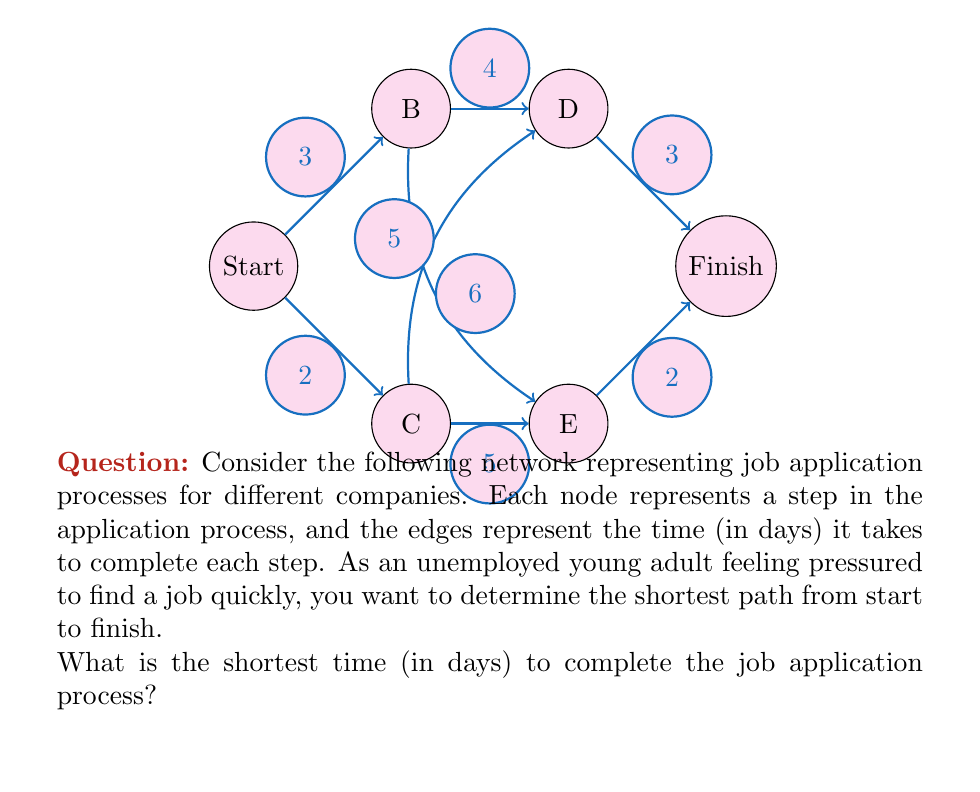Provide a solution to this math problem. To find the shortest path, we can use Dijkstra's algorithm or simply examine all possible paths from Start to Finish. Let's list all paths and their total times:

1. Start → B → D → Finish
   Time: $3 + 4 + 3 = 10$ days

2. Start → B → E → Finish
   Time: $3 + 6 + 2 = 11$ days

3. Start → C → D → Finish
   Time: $2 + 5 + 3 = 10$ days

4. Start → C → E → Finish
   Time: $2 + 5 + 2 = 9$ days

The shortest path is Start → C → E → Finish, taking 9 days in total.

This path represents:
1. Applying to company C (2 days)
2. Moving through their application process to stage E (5 days)
3. Completing the final stage to finish the process (2 days)

This result aligns with the persona of an unemployed young adult feeling pressured, as it provides the quickest route to potentially securing employment.
Answer: 9 days 